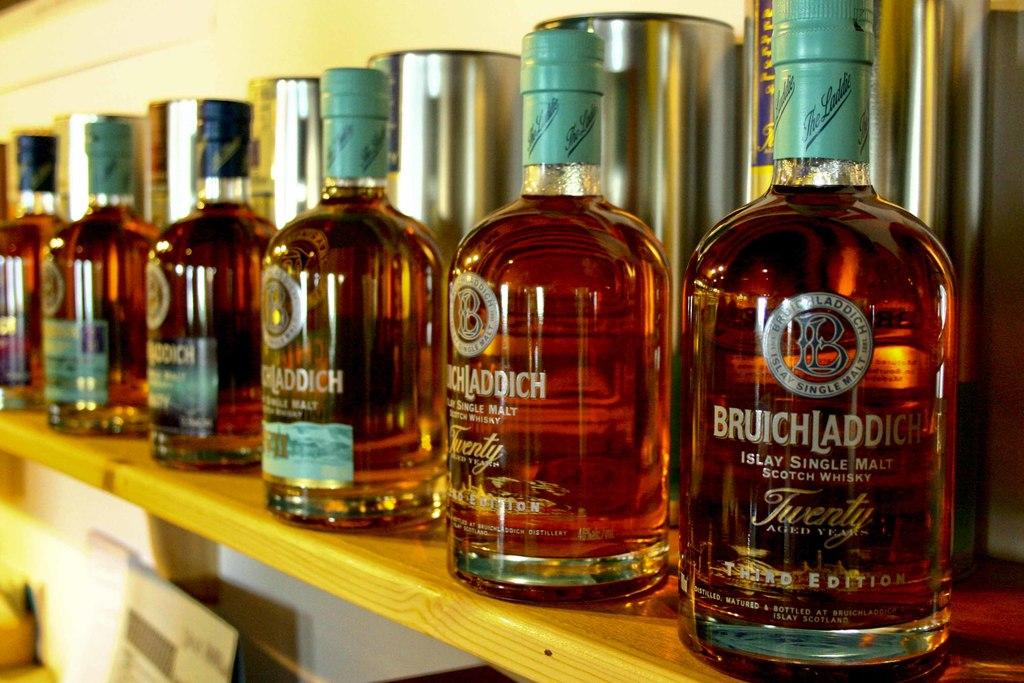<image>
Describe the image concisely. Six bottles of a special edition of Bruichladdich scotch next to each other on a top wooden shelf and with their metallic boxes behind. 